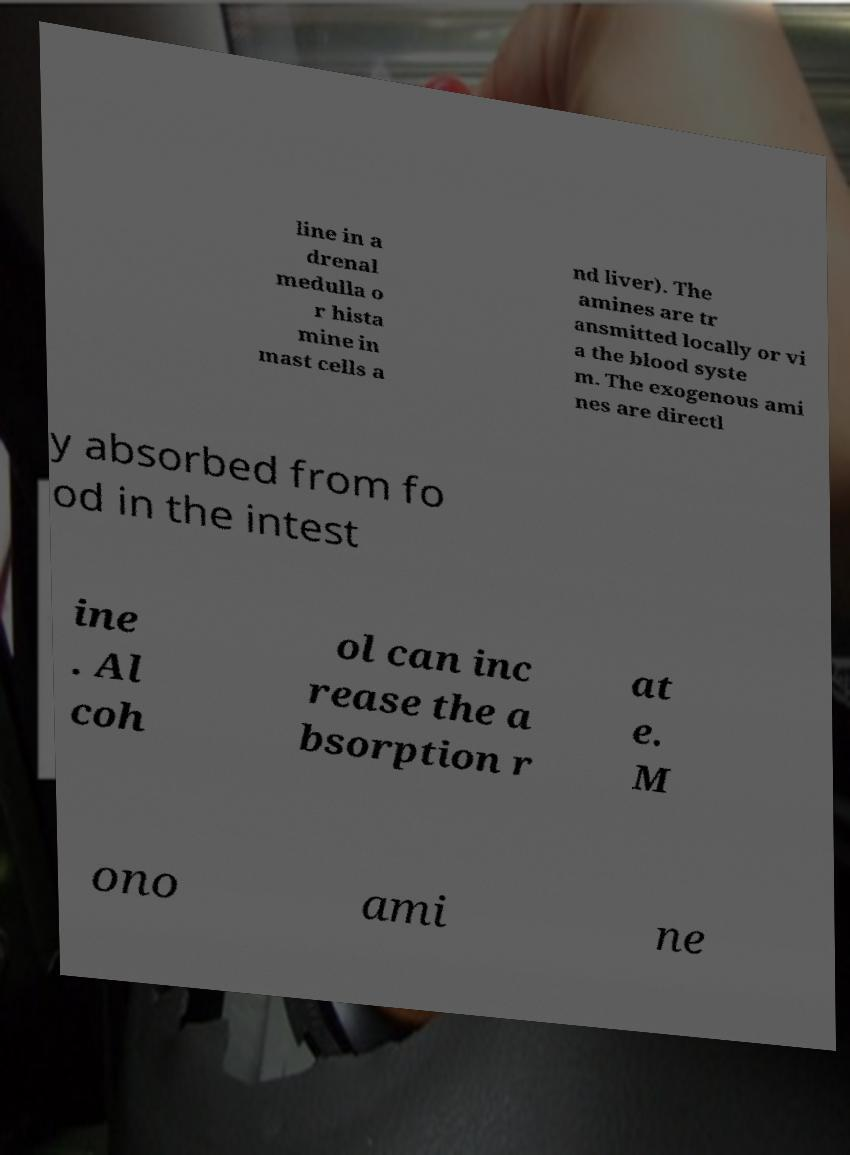I need the written content from this picture converted into text. Can you do that? line in a drenal medulla o r hista mine in mast cells a nd liver). The amines are tr ansmitted locally or vi a the blood syste m. The exogenous ami nes are directl y absorbed from fo od in the intest ine . Al coh ol can inc rease the a bsorption r at e. M ono ami ne 